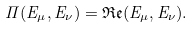<formula> <loc_0><loc_0><loc_500><loc_500>\Pi ( E _ { \mu } , E _ { \nu } ) = \mathfrak { R e } ( E _ { \mu } , E _ { \nu } ) .</formula> 